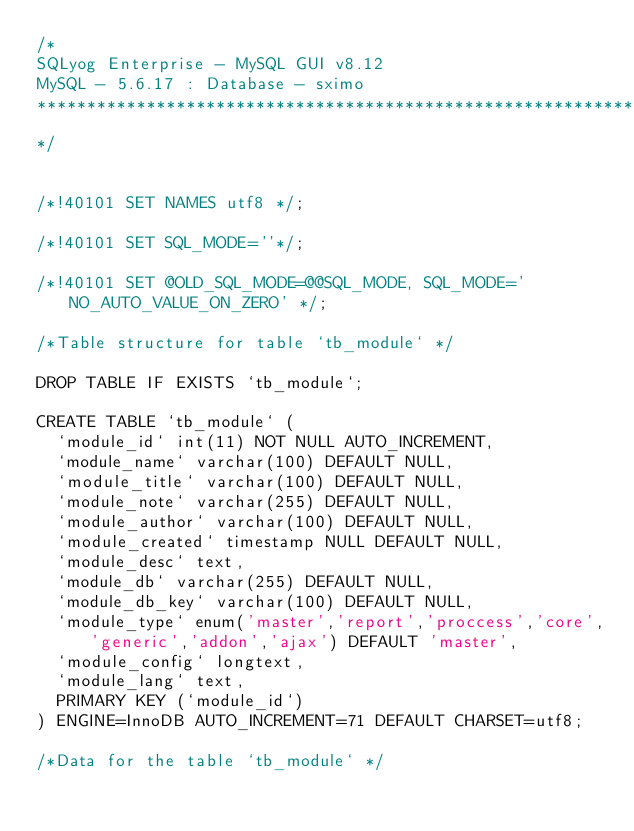Convert code to text. <code><loc_0><loc_0><loc_500><loc_500><_SQL_>/*
SQLyog Enterprise - MySQL GUI v8.12 
MySQL - 5.6.17 : Database - sximo
*********************************************************************
*/

/*!40101 SET NAMES utf8 */;

/*!40101 SET SQL_MODE=''*/;

/*!40101 SET @OLD_SQL_MODE=@@SQL_MODE, SQL_MODE='NO_AUTO_VALUE_ON_ZERO' */;

/*Table structure for table `tb_module` */

DROP TABLE IF EXISTS `tb_module`;

CREATE TABLE `tb_module` (
  `module_id` int(11) NOT NULL AUTO_INCREMENT,
  `module_name` varchar(100) DEFAULT NULL,
  `module_title` varchar(100) DEFAULT NULL,
  `module_note` varchar(255) DEFAULT NULL,
  `module_author` varchar(100) DEFAULT NULL,
  `module_created` timestamp NULL DEFAULT NULL,
  `module_desc` text,
  `module_db` varchar(255) DEFAULT NULL,
  `module_db_key` varchar(100) DEFAULT NULL,
  `module_type` enum('master','report','proccess','core','generic','addon','ajax') DEFAULT 'master',
  `module_config` longtext,
  `module_lang` text,
  PRIMARY KEY (`module_id`)
) ENGINE=InnoDB AUTO_INCREMENT=71 DEFAULT CHARSET=utf8;

/*Data for the table `tb_module` */
</code> 